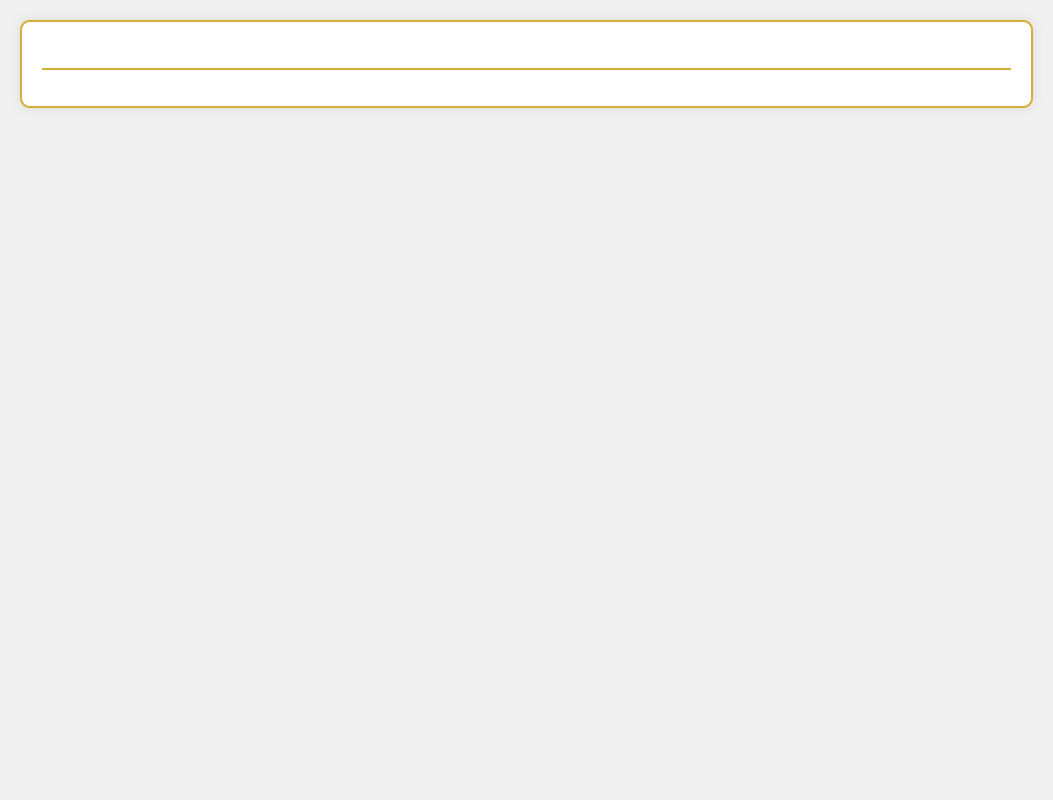what is the title of the patent application? The title is mentioned at the top of the document as the main heading.
Answer: Innovative Border Control System Utilizing Biometric Verification for Post-Brexit UK who is the intended audience for the patent application? The intended audience is typically specified in the abstract or introduction, referencing stakeholders or interests in the technology.
Answer: Border control authorities what innovative technology is described in the application? The specific technology is usually listed in the abstract as a focus of the patent.
Answer: Biometric verification how many advantages does the document list? The number of advantages is typically delineated in the advantages section of the document.
Answer: Several what is the primary benefit mentioned for the border control system? The primary benefit can often be found in the advantages section, highlighting improvements or efficiencies.
Answer: Enhanced security what kind of claims are included in the patent application? Claims outline the specific novel aspects of the technology and can be found in a dedicated section.
Answer: Biometric data processing when was the patent application submitted? The submission date is usually included in the footer or introductory sections of a patent document.
Answer: October 2023 how is the biometric verification process described? The description of the process is detailed in the abstract or claims, focusing on the method's steps.
Answer: Automated and secure where can the application be accessed for further review? Access details are usually included in the header or footer, often referencing a website or patent office.
Answer: Patent office website 